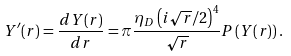<formula> <loc_0><loc_0><loc_500><loc_500>Y ^ { \prime } ( r ) = \frac { d Y ( r ) } { d r } = \pi \frac { \eta _ { D } \left ( i \sqrt { r } / 2 \right ) ^ { 4 } } { \sqrt { r } } P \left ( Y ( r ) \right ) .</formula> 